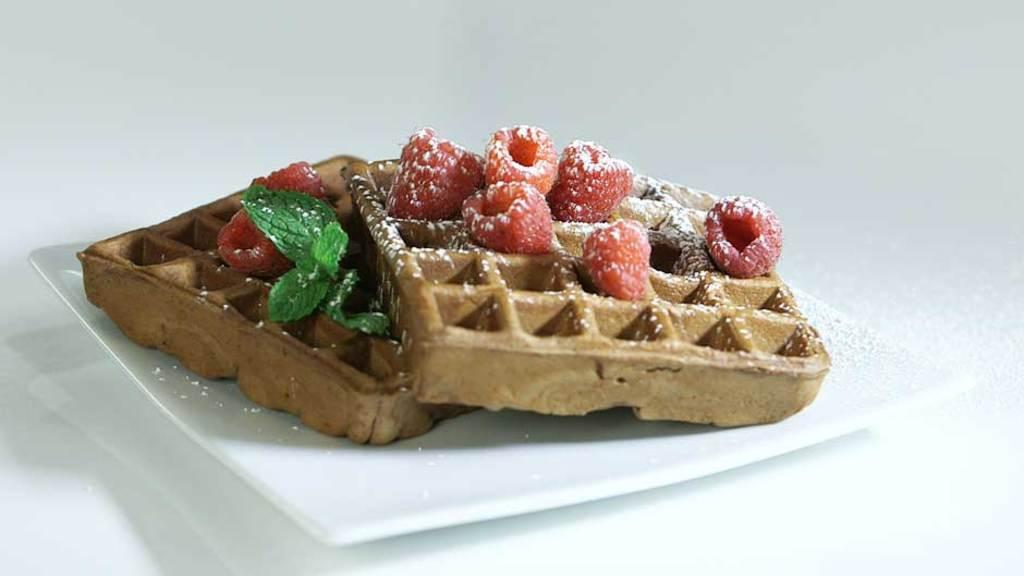What type of fruit is present in the image? There are strawberries in the image. What type of snack is also present in the image? There are crunch biscuits in the image. Where are the strawberries and crunch biscuits placed? The strawberries and crunch biscuits are on a white plate. On what surface is the white plate placed? The white plate is placed on a table. What type of toad can be seen giving approval in the image? There is no toad present in the image, and no one is giving approval. 